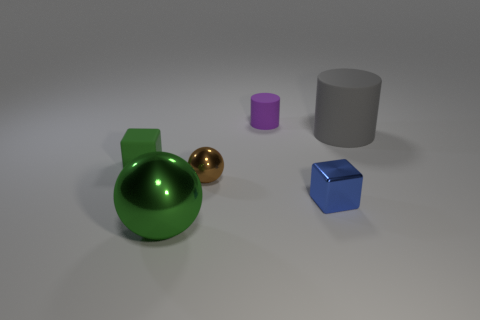Subtract 1 cylinders. How many cylinders are left? 1 Add 2 rubber cylinders. How many objects exist? 8 Subtract all spheres. How many objects are left? 4 Subtract all green balls. Subtract all brown cylinders. How many balls are left? 1 Subtract all purple spheres. How many green cylinders are left? 0 Subtract all blue shiny things. Subtract all green rubber things. How many objects are left? 4 Add 3 large metallic things. How many large metallic things are left? 4 Add 1 matte things. How many matte things exist? 4 Subtract 0 purple balls. How many objects are left? 6 